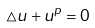Convert formula to latex. <formula><loc_0><loc_0><loc_500><loc_500>\triangle u + u ^ { p } = 0</formula> 